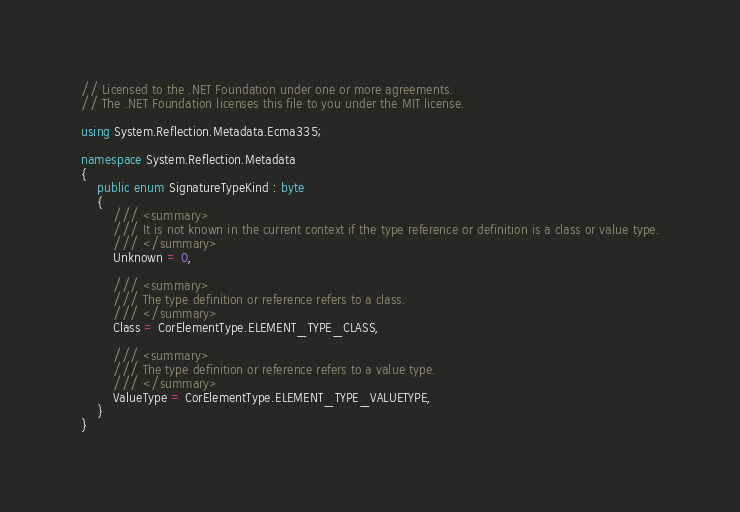<code> <loc_0><loc_0><loc_500><loc_500><_C#_>// Licensed to the .NET Foundation under one or more agreements.
// The .NET Foundation licenses this file to you under the MIT license.

using System.Reflection.Metadata.Ecma335;

namespace System.Reflection.Metadata
{
    public enum SignatureTypeKind : byte
    {
        /// <summary>
        /// It is not known in the current context if the type reference or definition is a class or value type.
        /// </summary>
        Unknown = 0,

        /// <summary>
        /// The type definition or reference refers to a class.
        /// </summary>
        Class = CorElementType.ELEMENT_TYPE_CLASS,

        /// <summary>
        /// The type definition or reference refers to a value type.
        /// </summary>
        ValueType = CorElementType.ELEMENT_TYPE_VALUETYPE,
    }
}
</code> 